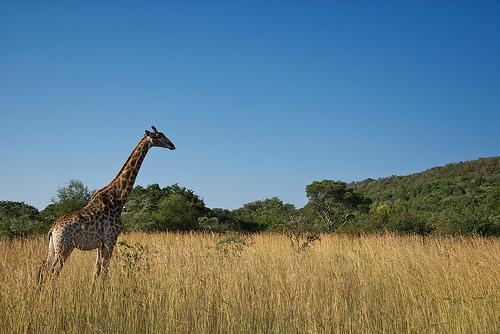Provide a concise description of the main object and its environment in the picture. The image depicts a giraffe facing right in a field of grass, with a cloudless blue sky above and trees in the background. Offer a brief account of the main element in the picture and its actions. A giraffe, bearing horns and open eyes, faces right while standing in tall, golden grass, near trees and a small tree. Report the key features of the picture, including the main subject and its backdrop. A tall, brown and white giraffe with open eyes stands in a field of tall grass, with trees in the background and a blue cloudless sky. Briefly describe the essential elements and atmosphere present in the image. A giraffe with open eyes and horns amidst tall grass, facing right, surrounded by trees and under a cloudless blue sky. Capture the essence of the image, emphasizing the leading subject and its context. A brown giraffe gazes rightward in a field of tall grass, accompanied by a clear blue sky and the presence of trees in the backdrop. Write a brief overview of the primary subject and its surroundings in the image. A tall giraffe, having horns and open eyes, stands amidst tall grass in a field, with background having green trees and a clear blue sky. Mention the principal figure in the photograph and summarize its actions. A brown giraffe with white spots leans forward, gazing right in a field of tall grass, while its eye remains open. Describe the scene portrayed in the image highlighting the key features. The image shows a brown and white giraffe standing in long golden grass, facing right, with trees and bushes in the background. Give a succinct summary of the primary subject and their environment in the image. The image portrays a giraffe with horns leaning forward, standing in tall grass with trees and a clear blue sky in the background. Sum up the primary focus of the image and its setting. A giraffe, looking rightwards and leaning forward, stands in a field of tall grass, under a clear blue sky and near a small tree. 